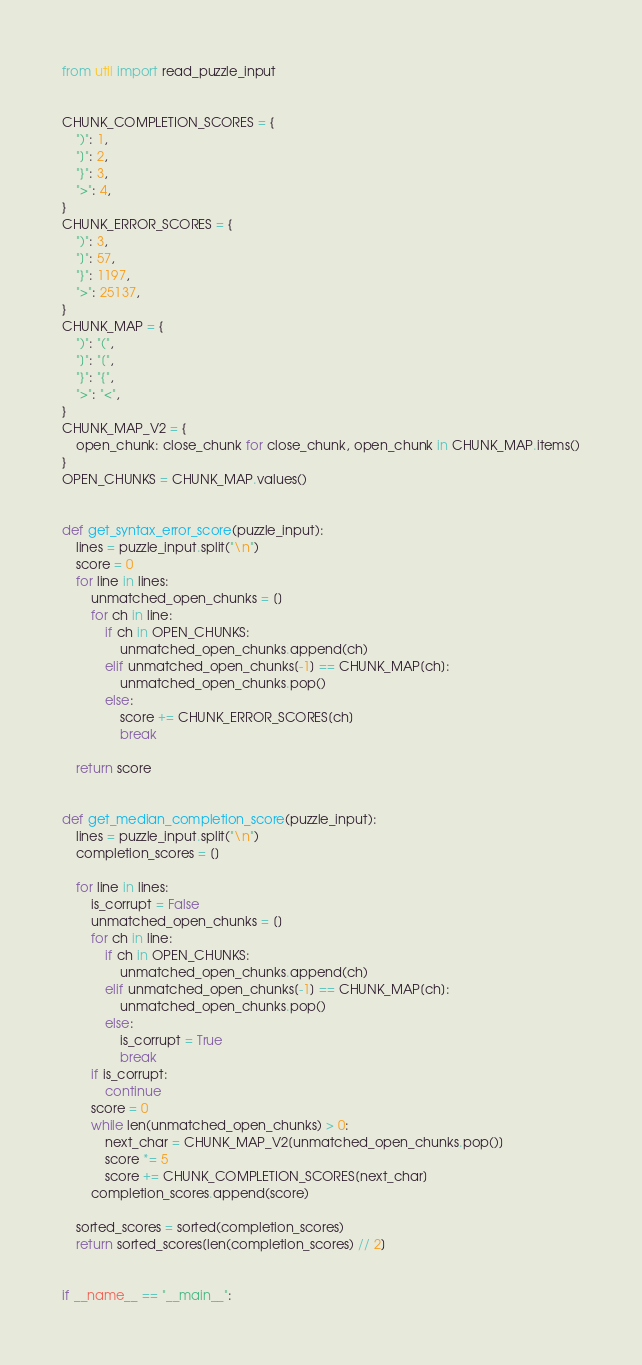<code> <loc_0><loc_0><loc_500><loc_500><_Python_>from util import read_puzzle_input


CHUNK_COMPLETION_SCORES = {
    ")": 1,
    "]": 2,
    "}": 3,
    ">": 4,
}
CHUNK_ERROR_SCORES = {
    ")": 3,
    "]": 57,
    "}": 1197,
    ">": 25137,
}
CHUNK_MAP = {
    ")": "(",
    "]": "[",
    "}": "{",
    ">": "<",
}
CHUNK_MAP_V2 = {
    open_chunk: close_chunk for close_chunk, open_chunk in CHUNK_MAP.items()
}
OPEN_CHUNKS = CHUNK_MAP.values()


def get_syntax_error_score(puzzle_input):
    lines = puzzle_input.split("\n")
    score = 0
    for line in lines:
        unmatched_open_chunks = []
        for ch in line:
            if ch in OPEN_CHUNKS:
                unmatched_open_chunks.append(ch)
            elif unmatched_open_chunks[-1] == CHUNK_MAP[ch]:
                unmatched_open_chunks.pop()
            else:
                score += CHUNK_ERROR_SCORES[ch]
                break

    return score


def get_median_completion_score(puzzle_input):
    lines = puzzle_input.split("\n")
    completion_scores = []

    for line in lines:
        is_corrupt = False
        unmatched_open_chunks = []
        for ch in line:
            if ch in OPEN_CHUNKS:
                unmatched_open_chunks.append(ch)
            elif unmatched_open_chunks[-1] == CHUNK_MAP[ch]:
                unmatched_open_chunks.pop()
            else:
                is_corrupt = True
                break
        if is_corrupt:
            continue
        score = 0
        while len(unmatched_open_chunks) > 0:
            next_char = CHUNK_MAP_V2[unmatched_open_chunks.pop()]
            score *= 5
            score += CHUNK_COMPLETION_SCORES[next_char]
        completion_scores.append(score)

    sorted_scores = sorted(completion_scores)
    return sorted_scores[len(completion_scores) // 2]


if __name__ == "__main__":</code> 